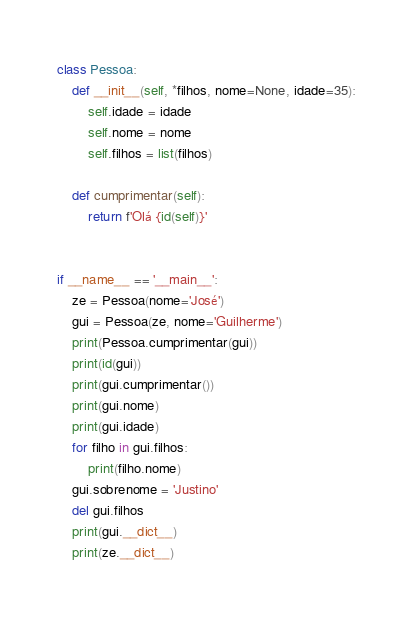<code> <loc_0><loc_0><loc_500><loc_500><_Python_>class Pessoa:
    def __init__(self, *filhos, nome=None, idade=35):
        self.idade = idade
        self.nome = nome
        self.filhos = list(filhos)

    def cumprimentar(self):
        return f'Olá {id(self)}'


if __name__ == '__main__':
    ze = Pessoa(nome='José')
    gui = Pessoa(ze, nome='Guilherme')
    print(Pessoa.cumprimentar(gui))
    print(id(gui))
    print(gui.cumprimentar())
    print(gui.nome)
    print(gui.idade)
    for filho in gui.filhos:
        print(filho.nome)
    gui.sobrenome = 'Justino'
    del gui.filhos
    print(gui.__dict__)
    print(ze.__dict__)

</code> 